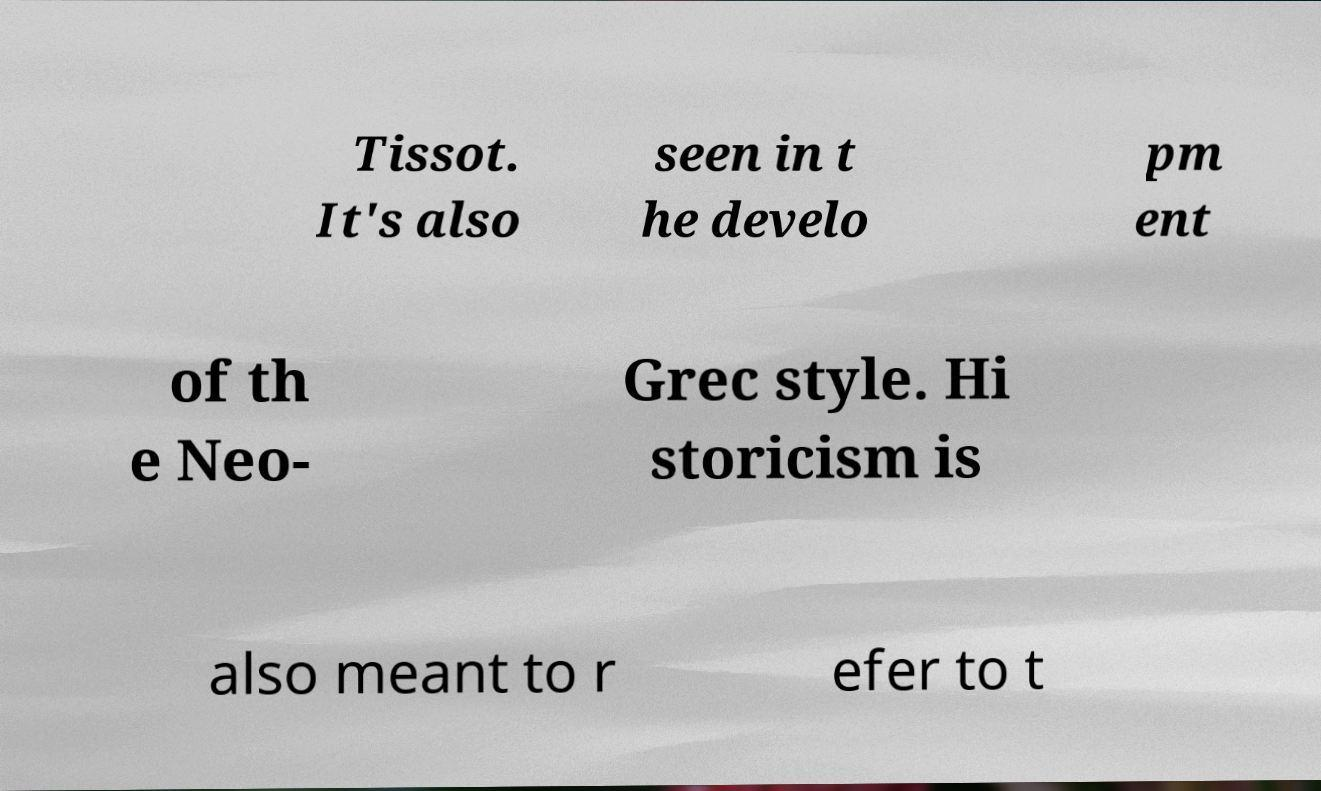Please read and relay the text visible in this image. What does it say? Tissot. It's also seen in t he develo pm ent of th e Neo- Grec style. Hi storicism is also meant to r efer to t 